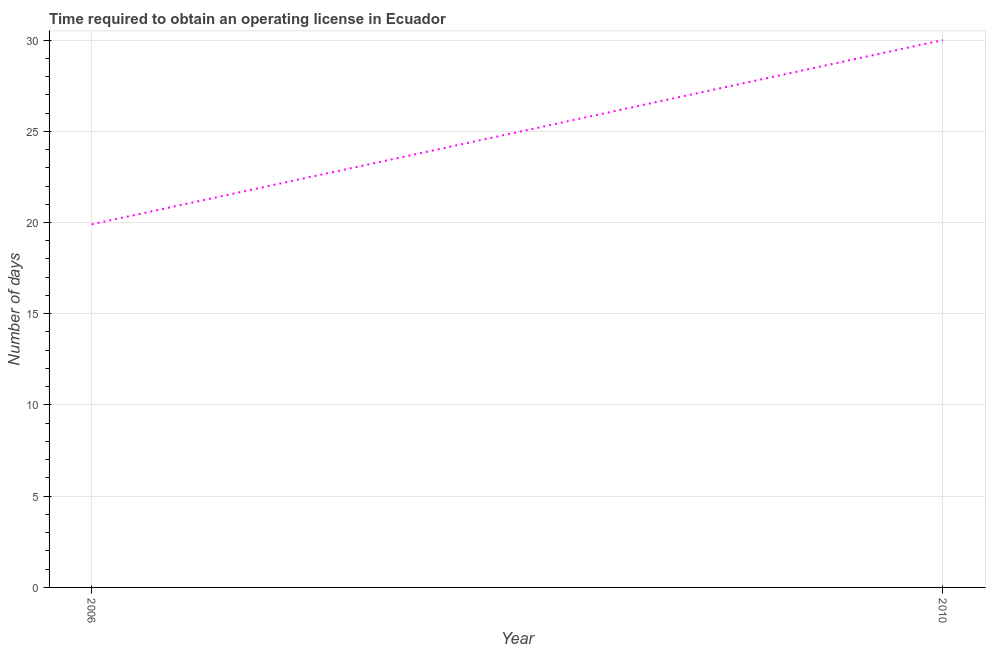What is the number of days to obtain operating license in 2006?
Offer a terse response. 19.9. Across all years, what is the maximum number of days to obtain operating license?
Offer a very short reply. 30. In which year was the number of days to obtain operating license maximum?
Your answer should be very brief. 2010. What is the sum of the number of days to obtain operating license?
Ensure brevity in your answer.  49.9. What is the difference between the number of days to obtain operating license in 2006 and 2010?
Give a very brief answer. -10.1. What is the average number of days to obtain operating license per year?
Your answer should be very brief. 24.95. What is the median number of days to obtain operating license?
Offer a very short reply. 24.95. What is the ratio of the number of days to obtain operating license in 2006 to that in 2010?
Your answer should be very brief. 0.66. Is the number of days to obtain operating license in 2006 less than that in 2010?
Keep it short and to the point. Yes. In how many years, is the number of days to obtain operating license greater than the average number of days to obtain operating license taken over all years?
Make the answer very short. 1. Does the graph contain any zero values?
Provide a succinct answer. No. Does the graph contain grids?
Your answer should be very brief. Yes. What is the title of the graph?
Ensure brevity in your answer.  Time required to obtain an operating license in Ecuador. What is the label or title of the Y-axis?
Give a very brief answer. Number of days. What is the Number of days of 2010?
Provide a short and direct response. 30. What is the difference between the Number of days in 2006 and 2010?
Give a very brief answer. -10.1. What is the ratio of the Number of days in 2006 to that in 2010?
Provide a short and direct response. 0.66. 